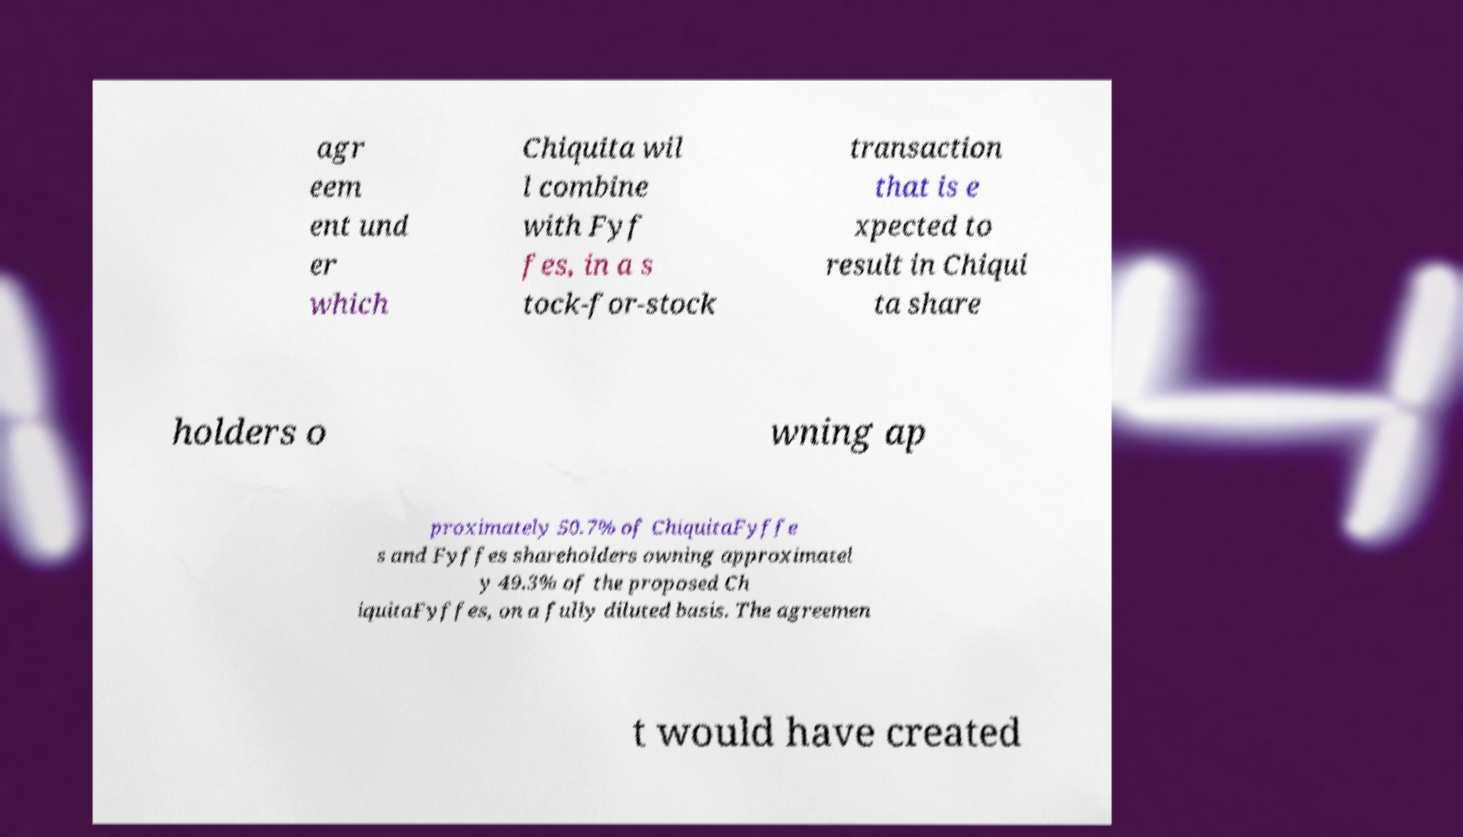What messages or text are displayed in this image? I need them in a readable, typed format. agr eem ent und er which Chiquita wil l combine with Fyf fes, in a s tock-for-stock transaction that is e xpected to result in Chiqui ta share holders o wning ap proximately 50.7% of ChiquitaFyffe s and Fyffes shareholders owning approximatel y 49.3% of the proposed Ch iquitaFyffes, on a fully diluted basis. The agreemen t would have created 